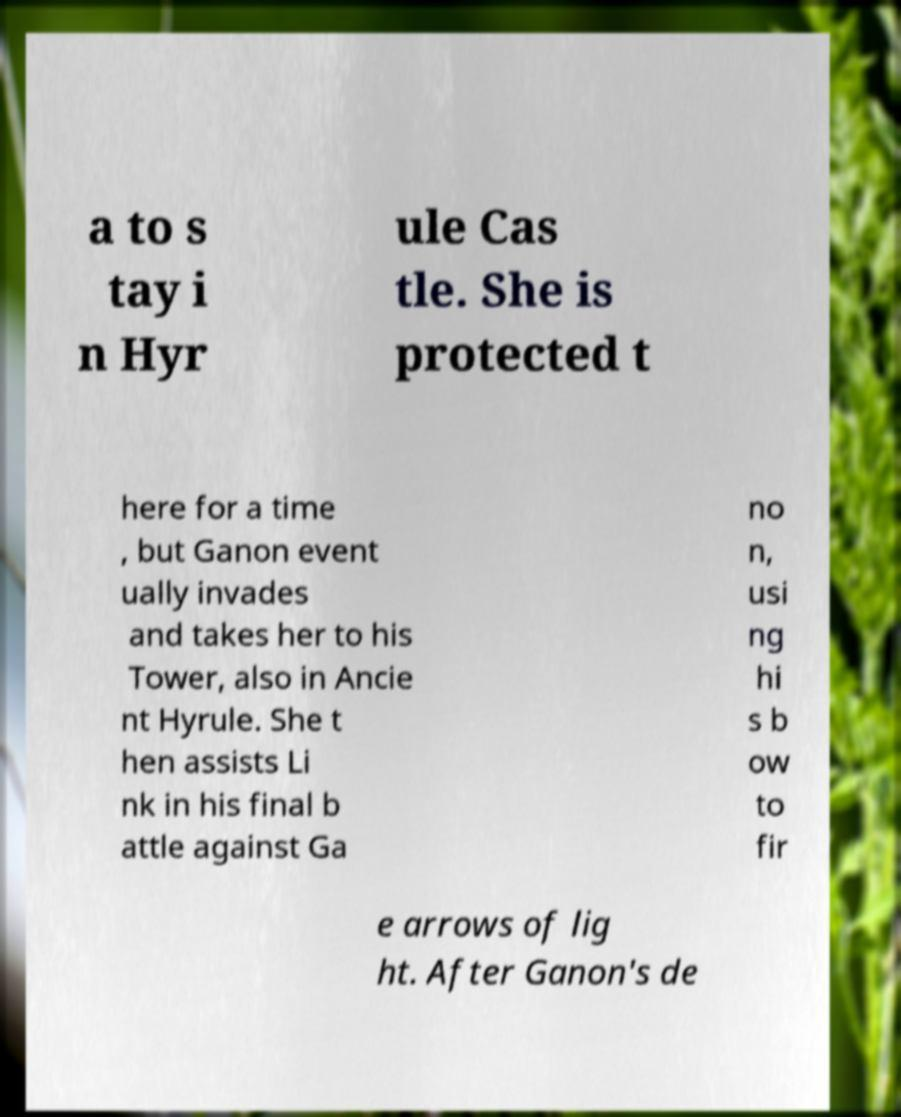Can you read and provide the text displayed in the image?This photo seems to have some interesting text. Can you extract and type it out for me? a to s tay i n Hyr ule Cas tle. She is protected t here for a time , but Ganon event ually invades and takes her to his Tower, also in Ancie nt Hyrule. She t hen assists Li nk in his final b attle against Ga no n, usi ng hi s b ow to fir e arrows of lig ht. After Ganon's de 